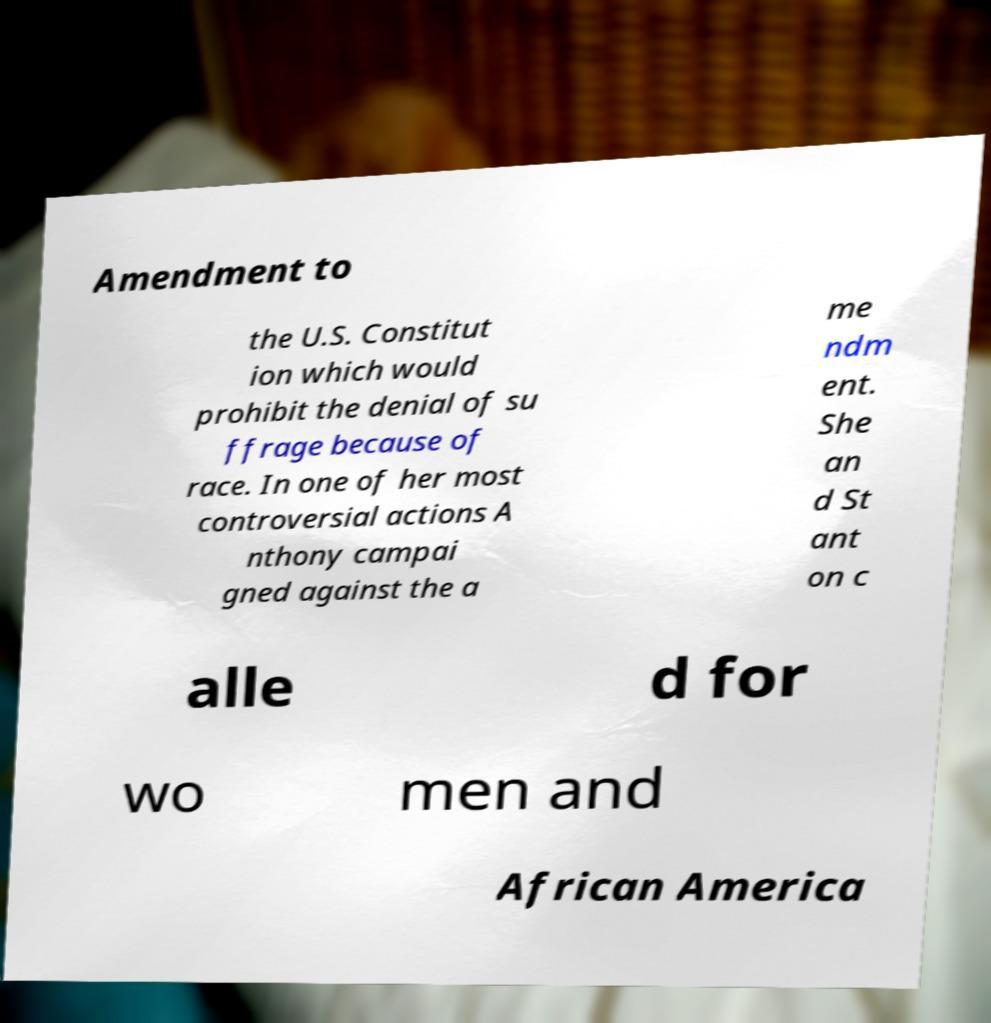Please identify and transcribe the text found in this image. Amendment to the U.S. Constitut ion which would prohibit the denial of su ffrage because of race. In one of her most controversial actions A nthony campai gned against the a me ndm ent. She an d St ant on c alle d for wo men and African America 